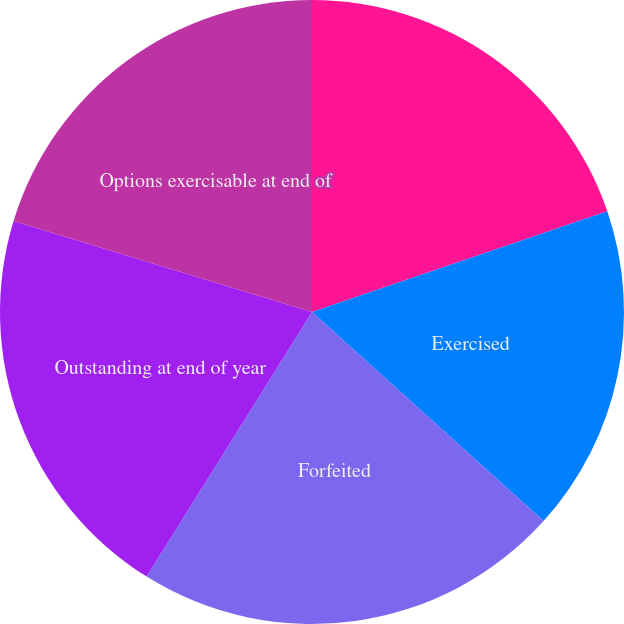Convert chart to OTSL. <chart><loc_0><loc_0><loc_500><loc_500><pie_chart><fcel>Outstanding at beginning of<fcel>Exercised<fcel>Forfeited<fcel>Outstanding at end of year<fcel>Options exercisable at end of<nl><fcel>19.77%<fcel>16.92%<fcel>22.2%<fcel>20.82%<fcel>20.29%<nl></chart> 